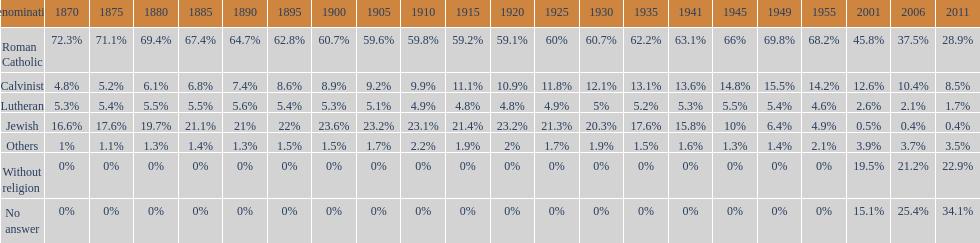How many denominations never dropped below 20%? 1. 